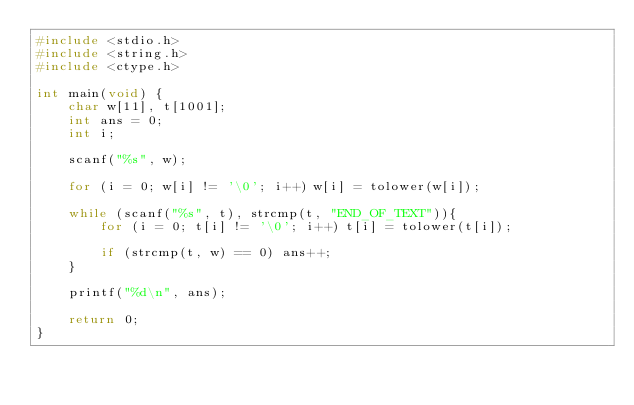Convert code to text. <code><loc_0><loc_0><loc_500><loc_500><_C_>#include <stdio.h>
#include <string.h>
#include <ctype.h>
 
int main(void) {
	char w[11], t[1001];
	int ans = 0;
	int i;
	
	scanf("%s", w);
	
	for (i = 0; w[i] != '\0'; i++) w[i] = tolower(w[i]);
	
	while (scanf("%s", t), strcmp(t, "END_OF_TEXT")){
		for (i = 0; t[i] != '\0'; i++) t[i] = tolower(t[i]);
		
		if (strcmp(t, w) == 0) ans++;
	}
	
	printf("%d\n", ans);
	
	return 0;
}</code> 